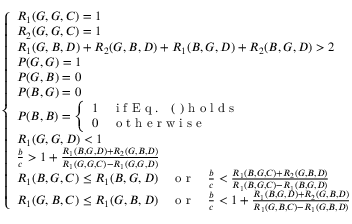<formula> <loc_0><loc_0><loc_500><loc_500>\begin{array} { r } { \left \{ \begin{array} { l l } { R _ { 1 } ( G , G , C ) = 1 } \\ { R _ { 2 } ( G , G , C ) = 1 } \\ { R _ { 1 } ( G , B , D ) + R _ { 2 } ( G , B , D ) + R _ { 1 } ( B , G , D ) + R _ { 2 } ( B , G , D ) > 2 } \\ { P ( G , G ) = 1 } \\ { P ( G , B ) = 0 } \\ { P ( B , G ) = 0 } \\ { P ( B , B ) = \left \{ \begin{array} { l l } { 1 } & { i f E q . ( ) h o l d s } \\ { 0 } & { o t h e r w i s e } \end{array} } \\ { R _ { 1 } ( G , G , D ) < 1 } \\ { \frac { b } { c } > 1 + \frac { R _ { 1 } ( B , G , D ) + R _ { 2 } ( G , B , D ) } { R _ { 1 } ( G , G , C ) - R _ { 1 } ( G , G , D ) } } \\ { R _ { 1 } ( B , G , C ) \leq R _ { 1 } ( B , G , D ) { \quad o r \quad } \frac { b } { c } < \frac { R _ { 1 } ( B , G , C ) + R _ { 2 } ( G , B , D ) } { R _ { 1 } ( B , G , C ) - R _ { 1 } ( B , G , D ) } } \\ { R _ { 1 } ( G , B , C ) \leq R _ { 1 } ( G , B , D ) { \quad o r \quad } \frac { b } { c } < 1 + \frac { R _ { 1 } ( B , G , D ) + R _ { 2 } ( G , B , D ) } { R _ { 1 } ( G , B , C ) - R _ { 1 } ( G , B , D ) } } \end{array} } \end{array}</formula> 